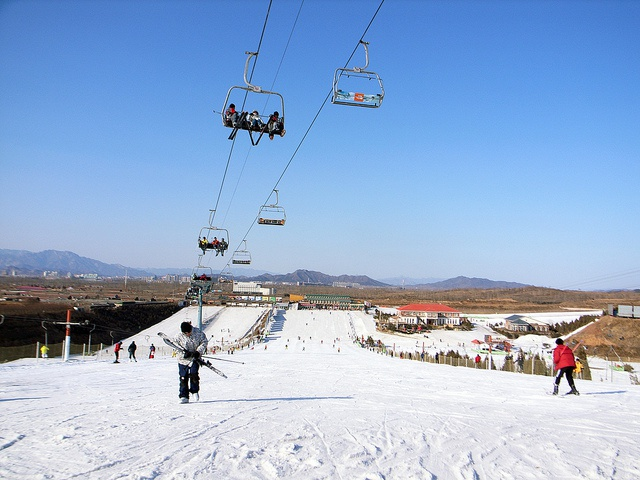Describe the objects in this image and their specific colors. I can see people in blue, white, darkgray, gray, and black tones, people in blue, black, lightgray, gray, and darkgray tones, people in blue, black, brown, and white tones, people in blue, black, gray, lightblue, and maroon tones, and skis in blue, darkgray, lightgray, gray, and black tones in this image. 